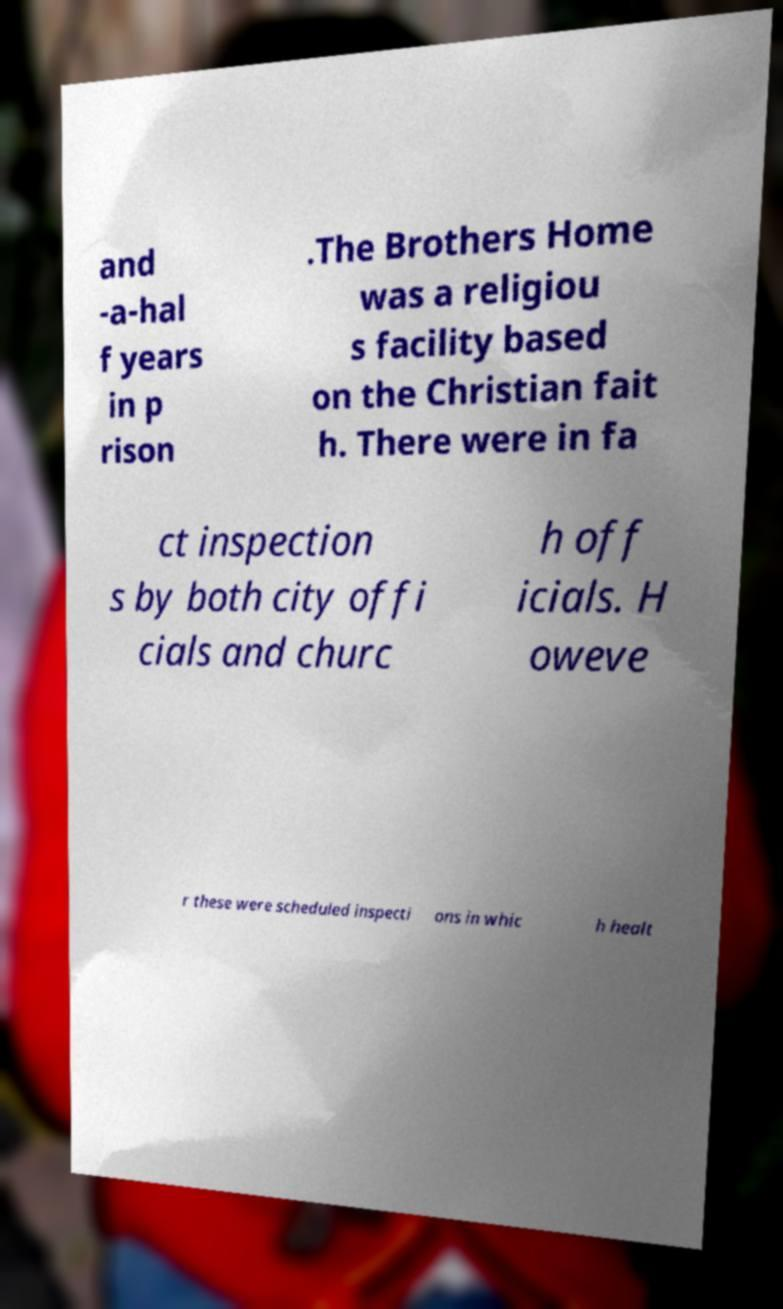Can you accurately transcribe the text from the provided image for me? and -a-hal f years in p rison .The Brothers Home was a religiou s facility based on the Christian fait h. There were in fa ct inspection s by both city offi cials and churc h off icials. H oweve r these were scheduled inspecti ons in whic h healt 